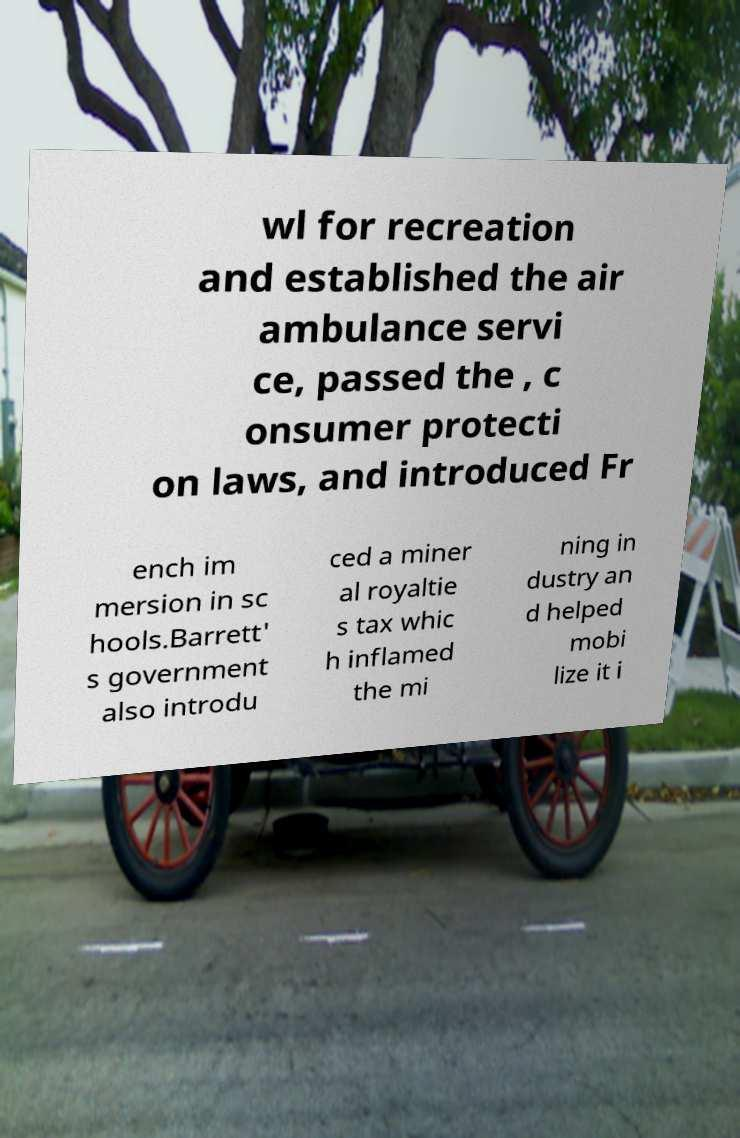There's text embedded in this image that I need extracted. Can you transcribe it verbatim? wl for recreation and established the air ambulance servi ce, passed the , c onsumer protecti on laws, and introduced Fr ench im mersion in sc hools.Barrett' s government also introdu ced a miner al royaltie s tax whic h inflamed the mi ning in dustry an d helped mobi lize it i 